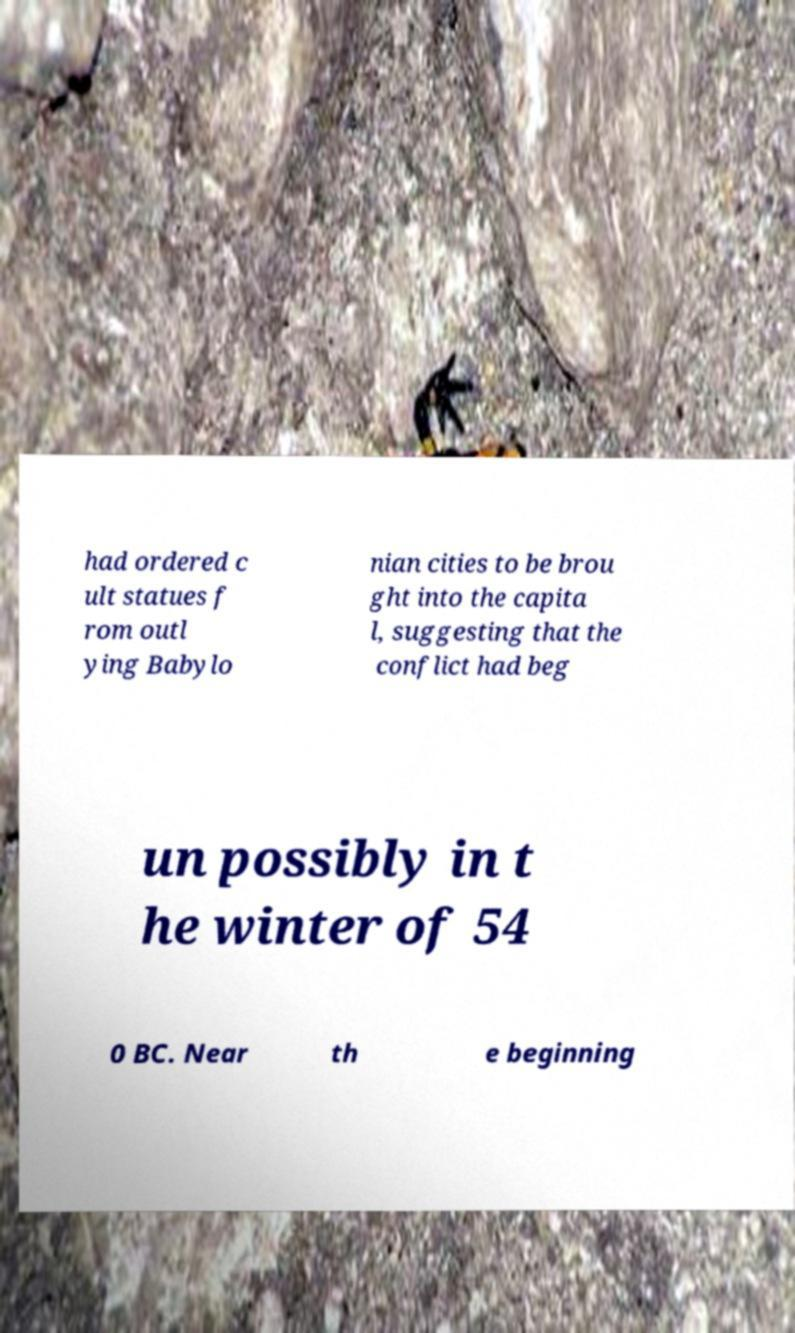What messages or text are displayed in this image? I need them in a readable, typed format. had ordered c ult statues f rom outl ying Babylo nian cities to be brou ght into the capita l, suggesting that the conflict had beg un possibly in t he winter of 54 0 BC. Near th e beginning 